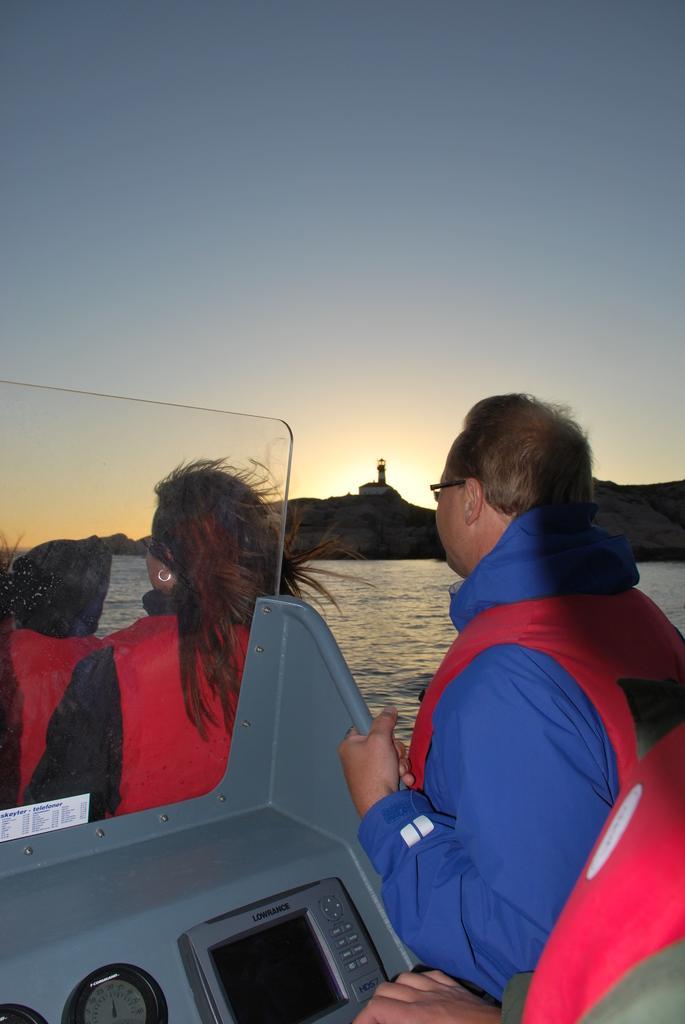In one or two sentences, can you explain what this image depicts? There are four persons standing in a boat. In the background we can see water,house,tower,mountain and sky. 